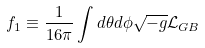Convert formula to latex. <formula><loc_0><loc_0><loc_500><loc_500>f _ { 1 } \equiv \frac { 1 } { 1 6 \pi } \int d \theta d \phi \sqrt { - g } \mathcal { L } _ { G B }</formula> 